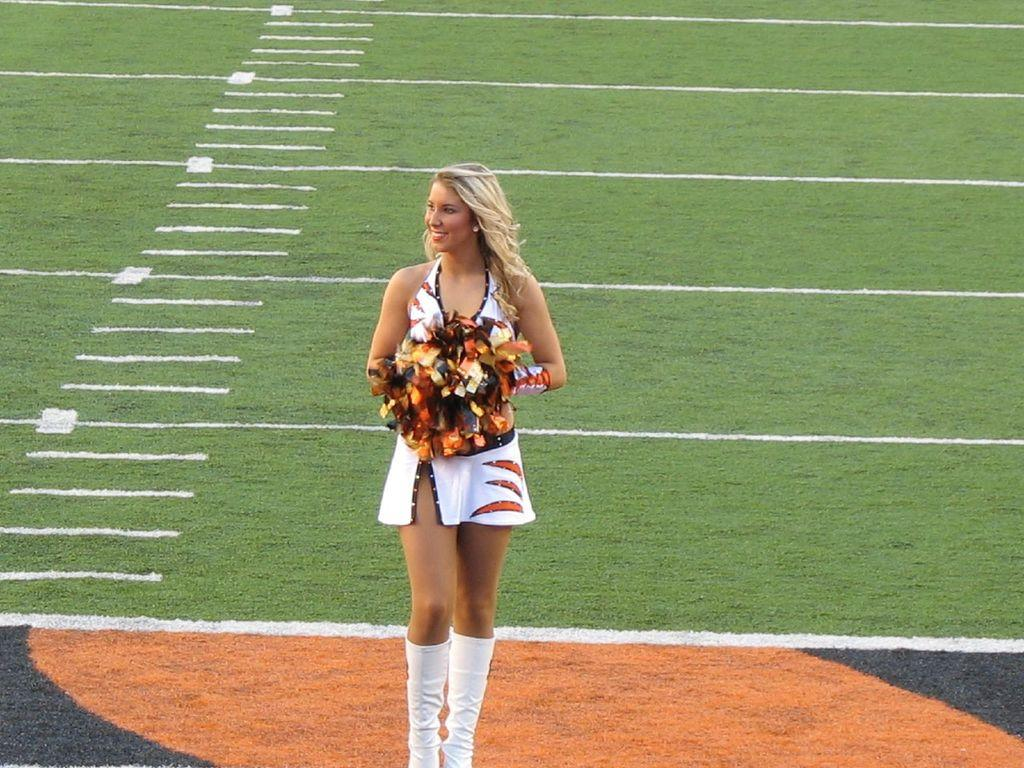Who is present in the image? There is a woman in the image. What is the woman holding in the image? The woman is holding glitter flowers. What can be inferred about the setting of the image? The image appears to be set on a ground or similar surface. How does the woman pull the substance out of the ground in the image? There is no substance being pulled out of the ground in the image. The woman is holding glitter flowers, and there is no indication of any substance being extracted from the ground. 